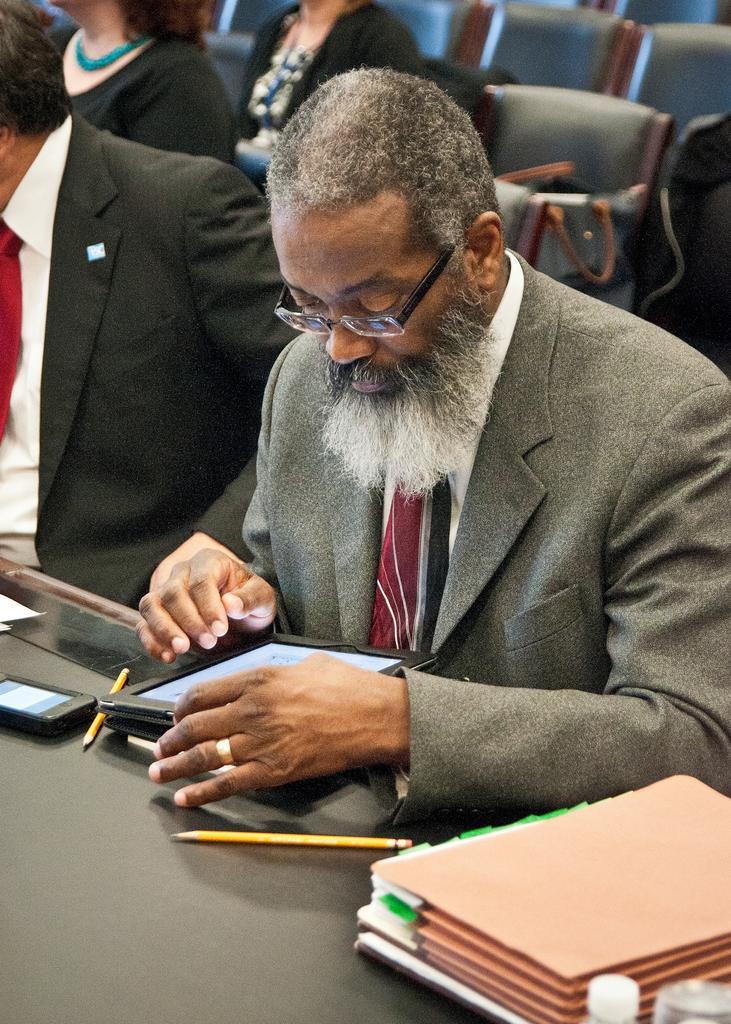How would you summarize this image in a sentence or two? In this image, we can see a person in a suit is sitting and seeing towards ipad. Here there is a black table, few things and objects are placed on it. Background we can see few people and chairs. 